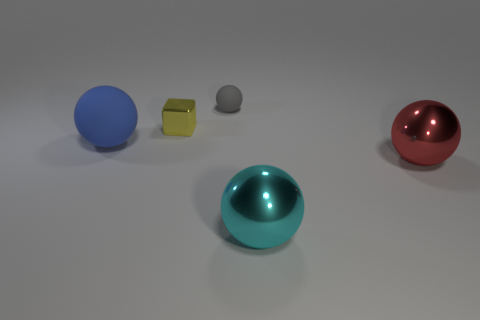Subtract all yellow spheres. Subtract all cyan cubes. How many spheres are left? 4 Add 2 big red shiny objects. How many objects exist? 7 Subtract all spheres. How many objects are left? 1 Subtract all green metallic blocks. Subtract all red shiny things. How many objects are left? 4 Add 3 big rubber objects. How many big rubber objects are left? 4 Add 5 tiny red shiny blocks. How many tiny red shiny blocks exist? 5 Subtract 0 cyan cylinders. How many objects are left? 5 